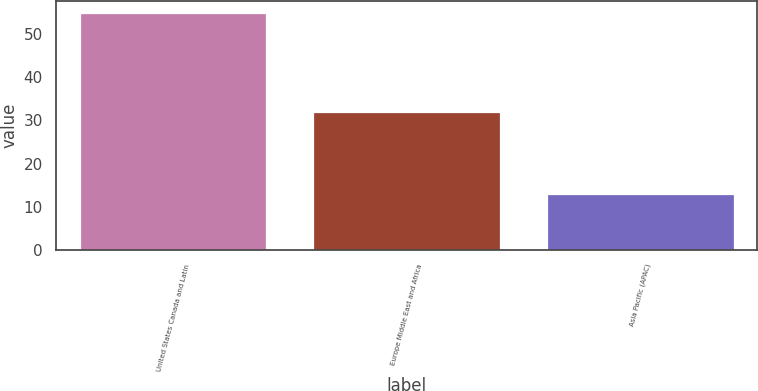<chart> <loc_0><loc_0><loc_500><loc_500><bar_chart><fcel>United States Canada and Latin<fcel>Europe Middle East and Africa<fcel>Asia Pacific (APAC)<nl><fcel>55<fcel>32<fcel>13<nl></chart> 